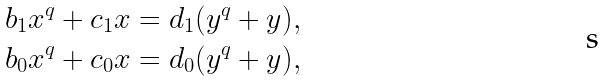Convert formula to latex. <formula><loc_0><loc_0><loc_500><loc_500>b _ { 1 } x ^ { q } + c _ { 1 } x & = d _ { 1 } ( y ^ { q } + y ) , \\ b _ { 0 } x ^ { q } + c _ { 0 } x & = d _ { 0 } ( y ^ { q } + y ) ,</formula> 